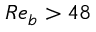<formula> <loc_0><loc_0><loc_500><loc_500>R e _ { b } > 4 8</formula> 